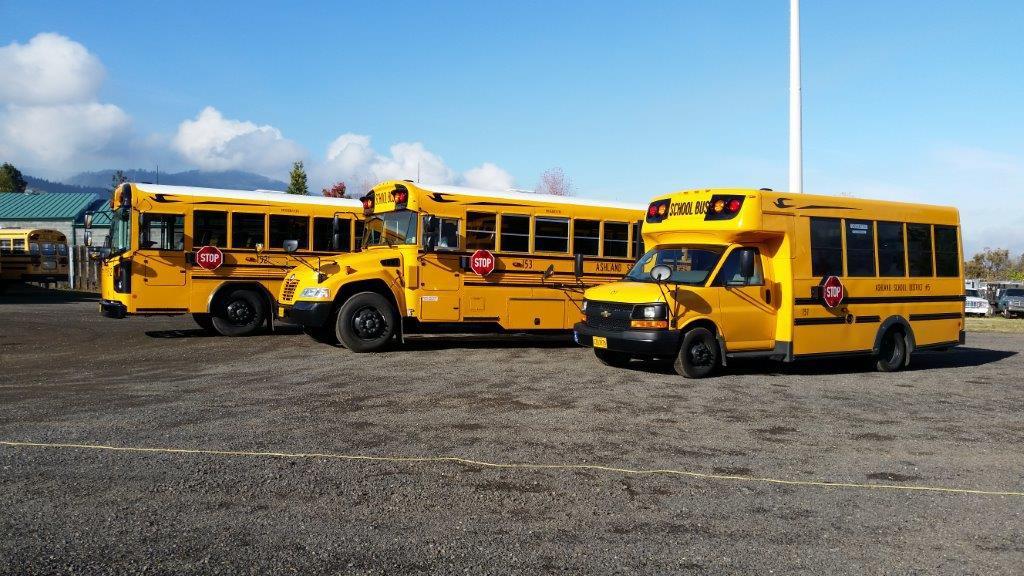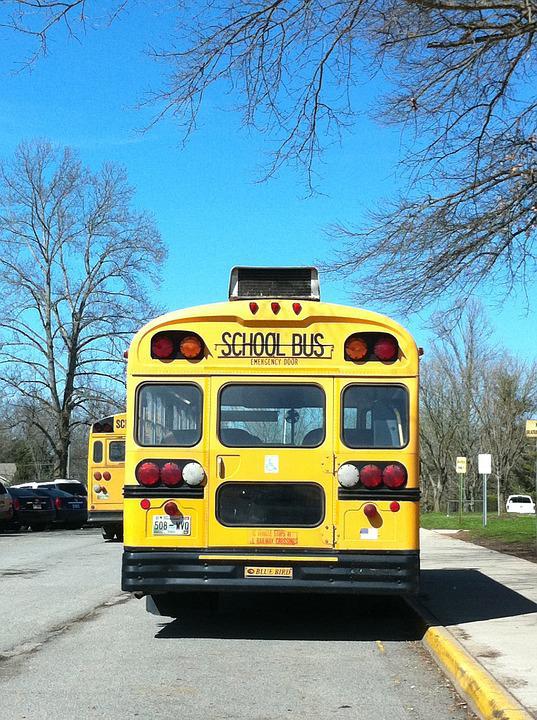The first image is the image on the left, the second image is the image on the right. Evaluate the accuracy of this statement regarding the images: "In at least one image there is an emergency exit in the back of the bus face forward with the front of the bus not visible.". Is it true? Answer yes or no. Yes. The first image is the image on the left, the second image is the image on the right. Assess this claim about the two images: "The right image shows a flat-fronted bus angled facing forward.". Correct or not? Answer yes or no. No. 